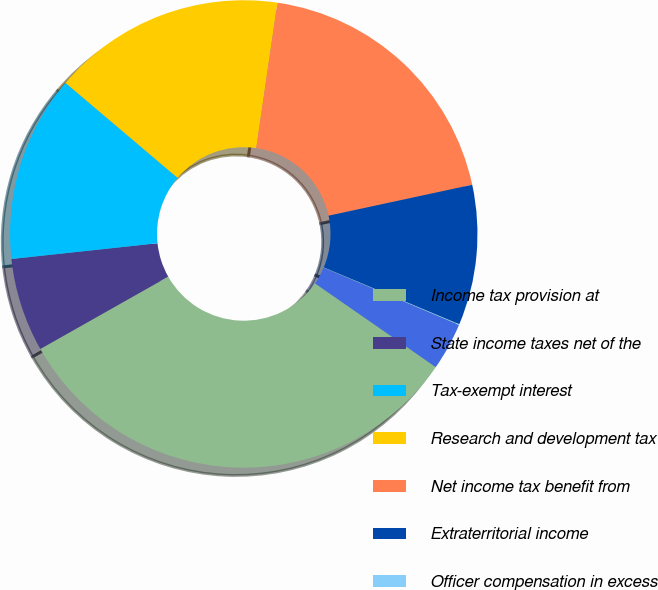Convert chart to OTSL. <chart><loc_0><loc_0><loc_500><loc_500><pie_chart><fcel>Income tax provision at<fcel>State income taxes net of the<fcel>Tax-exempt interest<fcel>Research and development tax<fcel>Net income tax benefit from<fcel>Extraterritorial income<fcel>Officer compensation in excess<fcel>Other<nl><fcel>32.16%<fcel>6.48%<fcel>12.9%<fcel>16.11%<fcel>19.32%<fcel>9.69%<fcel>0.06%<fcel>3.27%<nl></chart> 